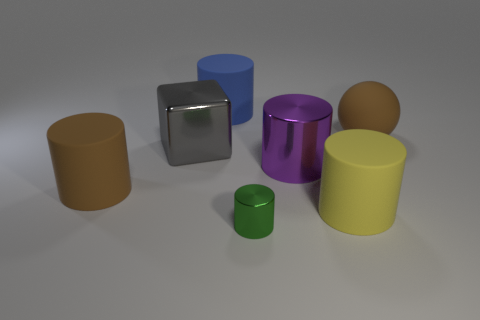Subtract all blue matte cylinders. How many cylinders are left? 4 Subtract all green cylinders. How many cylinders are left? 4 Subtract all red cylinders. Subtract all red cubes. How many cylinders are left? 5 Add 1 rubber cylinders. How many objects exist? 8 Subtract all blocks. How many objects are left? 6 Subtract 0 red blocks. How many objects are left? 7 Subtract all tiny metallic cylinders. Subtract all large cylinders. How many objects are left? 2 Add 3 large brown balls. How many large brown balls are left? 4 Add 1 small red rubber spheres. How many small red rubber spheres exist? 1 